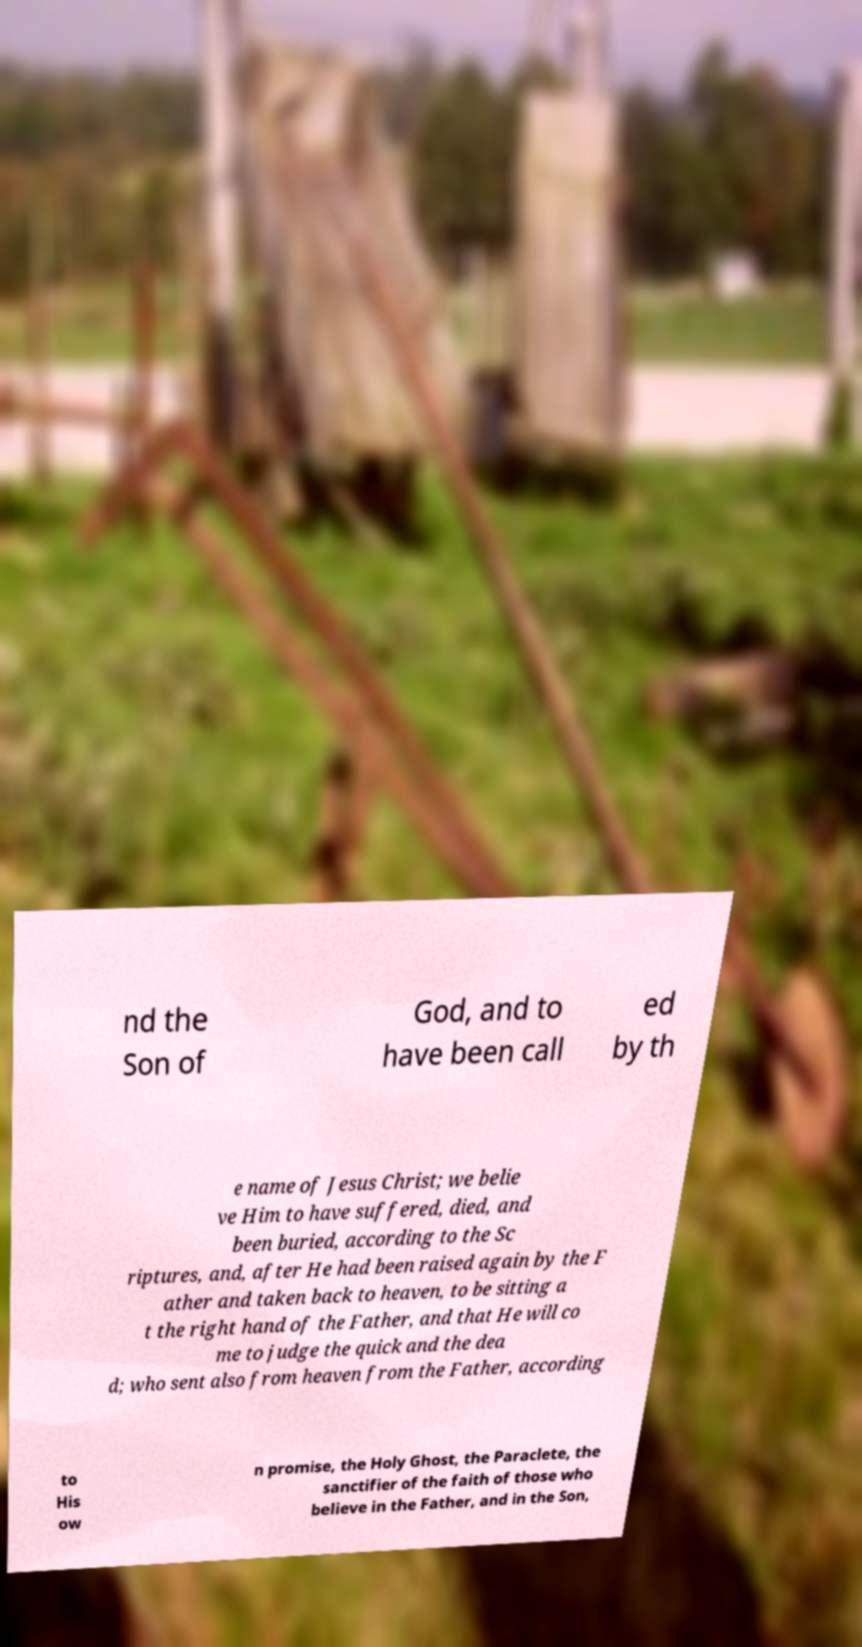Could you assist in decoding the text presented in this image and type it out clearly? nd the Son of God, and to have been call ed by th e name of Jesus Christ; we belie ve Him to have suffered, died, and been buried, according to the Sc riptures, and, after He had been raised again by the F ather and taken back to heaven, to be sitting a t the right hand of the Father, and that He will co me to judge the quick and the dea d; who sent also from heaven from the Father, according to His ow n promise, the Holy Ghost, the Paraclete, the sanctifier of the faith of those who believe in the Father, and in the Son, 